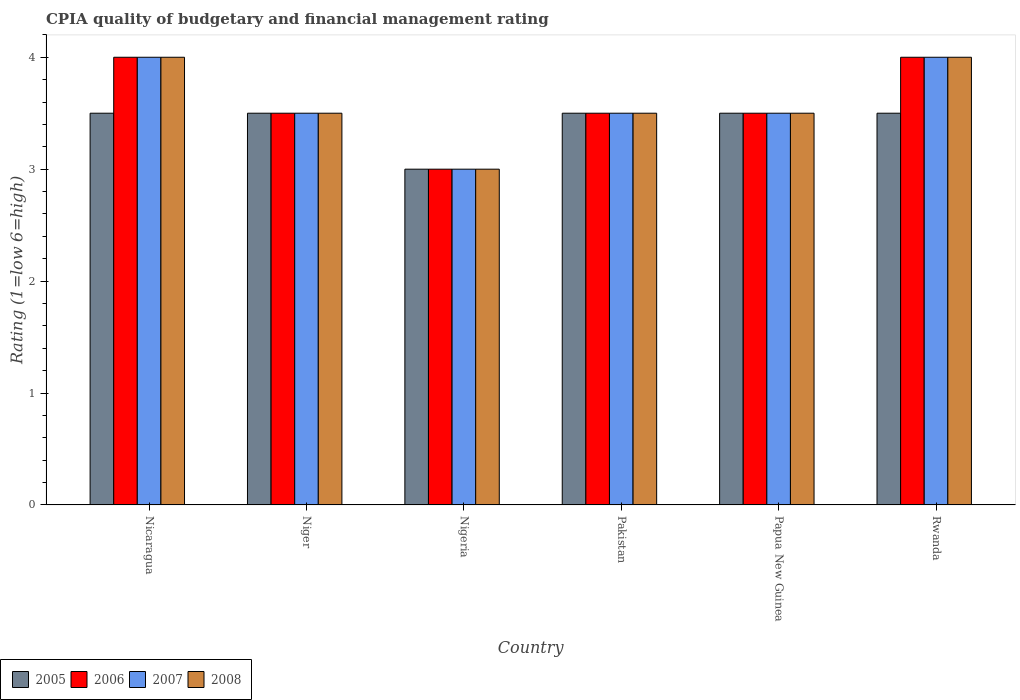How many different coloured bars are there?
Your response must be concise. 4. How many bars are there on the 1st tick from the left?
Your response must be concise. 4. In how many cases, is the number of bars for a given country not equal to the number of legend labels?
Make the answer very short. 0. Across all countries, what is the maximum CPIA rating in 2006?
Provide a short and direct response. 4. In which country was the CPIA rating in 2005 maximum?
Your response must be concise. Nicaragua. In which country was the CPIA rating in 2006 minimum?
Your answer should be very brief. Nigeria. What is the total CPIA rating in 2005 in the graph?
Your answer should be compact. 20.5. What is the average CPIA rating in 2008 per country?
Your response must be concise. 3.58. In how many countries, is the CPIA rating in 2008 greater than 0.8?
Ensure brevity in your answer.  6. Is the difference between the CPIA rating in 2005 in Nicaragua and Niger greater than the difference between the CPIA rating in 2007 in Nicaragua and Niger?
Make the answer very short. No. What is the difference between the highest and the lowest CPIA rating in 2007?
Offer a very short reply. 1. In how many countries, is the CPIA rating in 2005 greater than the average CPIA rating in 2005 taken over all countries?
Your answer should be very brief. 5. What does the 2nd bar from the left in Nigeria represents?
Give a very brief answer. 2006. Are all the bars in the graph horizontal?
Make the answer very short. No. How many countries are there in the graph?
Your response must be concise. 6. Does the graph contain any zero values?
Your answer should be compact. No. Does the graph contain grids?
Provide a succinct answer. No. How are the legend labels stacked?
Offer a very short reply. Horizontal. What is the title of the graph?
Your response must be concise. CPIA quality of budgetary and financial management rating. Does "2003" appear as one of the legend labels in the graph?
Ensure brevity in your answer.  No. What is the label or title of the Y-axis?
Offer a very short reply. Rating (1=low 6=high). What is the Rating (1=low 6=high) in 2005 in Nicaragua?
Ensure brevity in your answer.  3.5. What is the Rating (1=low 6=high) in 2007 in Nicaragua?
Provide a succinct answer. 4. What is the Rating (1=low 6=high) in 2008 in Nicaragua?
Provide a succinct answer. 4. What is the Rating (1=low 6=high) in 2005 in Niger?
Give a very brief answer. 3.5. What is the Rating (1=low 6=high) of 2005 in Nigeria?
Ensure brevity in your answer.  3. What is the Rating (1=low 6=high) in 2006 in Nigeria?
Provide a succinct answer. 3. What is the Rating (1=low 6=high) in 2007 in Nigeria?
Your answer should be compact. 3. What is the Rating (1=low 6=high) in 2008 in Nigeria?
Keep it short and to the point. 3. What is the Rating (1=low 6=high) in 2005 in Pakistan?
Make the answer very short. 3.5. What is the Rating (1=low 6=high) in 2006 in Pakistan?
Make the answer very short. 3.5. What is the Rating (1=low 6=high) of 2006 in Papua New Guinea?
Offer a terse response. 3.5. What is the Rating (1=low 6=high) of 2008 in Papua New Guinea?
Make the answer very short. 3.5. What is the Rating (1=low 6=high) in 2006 in Rwanda?
Keep it short and to the point. 4. Across all countries, what is the maximum Rating (1=low 6=high) of 2006?
Give a very brief answer. 4. Across all countries, what is the maximum Rating (1=low 6=high) of 2007?
Provide a short and direct response. 4. Across all countries, what is the maximum Rating (1=low 6=high) in 2008?
Your response must be concise. 4. What is the total Rating (1=low 6=high) of 2005 in the graph?
Provide a succinct answer. 20.5. What is the total Rating (1=low 6=high) of 2006 in the graph?
Ensure brevity in your answer.  21.5. What is the difference between the Rating (1=low 6=high) in 2005 in Nicaragua and that in Niger?
Your answer should be very brief. 0. What is the difference between the Rating (1=low 6=high) in 2008 in Nicaragua and that in Niger?
Make the answer very short. 0.5. What is the difference between the Rating (1=low 6=high) of 2005 in Nicaragua and that in Nigeria?
Your answer should be very brief. 0.5. What is the difference between the Rating (1=low 6=high) of 2007 in Nicaragua and that in Nigeria?
Your response must be concise. 1. What is the difference between the Rating (1=low 6=high) in 2008 in Nicaragua and that in Nigeria?
Ensure brevity in your answer.  1. What is the difference between the Rating (1=low 6=high) of 2005 in Nicaragua and that in Pakistan?
Provide a short and direct response. 0. What is the difference between the Rating (1=low 6=high) in 2007 in Nicaragua and that in Pakistan?
Provide a succinct answer. 0.5. What is the difference between the Rating (1=low 6=high) in 2008 in Nicaragua and that in Pakistan?
Give a very brief answer. 0.5. What is the difference between the Rating (1=low 6=high) of 2005 in Nicaragua and that in Papua New Guinea?
Provide a succinct answer. 0. What is the difference between the Rating (1=low 6=high) of 2006 in Nicaragua and that in Rwanda?
Your answer should be very brief. 0. What is the difference between the Rating (1=low 6=high) of 2008 in Nicaragua and that in Rwanda?
Make the answer very short. 0. What is the difference between the Rating (1=low 6=high) in 2006 in Niger and that in Nigeria?
Provide a succinct answer. 0.5. What is the difference between the Rating (1=low 6=high) in 2007 in Niger and that in Nigeria?
Make the answer very short. 0.5. What is the difference between the Rating (1=low 6=high) of 2005 in Niger and that in Pakistan?
Provide a short and direct response. 0. What is the difference between the Rating (1=low 6=high) of 2006 in Niger and that in Pakistan?
Keep it short and to the point. 0. What is the difference between the Rating (1=low 6=high) of 2008 in Niger and that in Papua New Guinea?
Give a very brief answer. 0. What is the difference between the Rating (1=low 6=high) in 2005 in Niger and that in Rwanda?
Offer a terse response. 0. What is the difference between the Rating (1=low 6=high) in 2007 in Niger and that in Rwanda?
Your response must be concise. -0.5. What is the difference between the Rating (1=low 6=high) in 2005 in Nigeria and that in Pakistan?
Your answer should be very brief. -0.5. What is the difference between the Rating (1=low 6=high) in 2006 in Nigeria and that in Pakistan?
Give a very brief answer. -0.5. What is the difference between the Rating (1=low 6=high) of 2005 in Nigeria and that in Rwanda?
Offer a terse response. -0.5. What is the difference between the Rating (1=low 6=high) in 2006 in Nigeria and that in Rwanda?
Your response must be concise. -1. What is the difference between the Rating (1=low 6=high) of 2007 in Nigeria and that in Rwanda?
Give a very brief answer. -1. What is the difference between the Rating (1=low 6=high) in 2008 in Nigeria and that in Rwanda?
Your answer should be very brief. -1. What is the difference between the Rating (1=low 6=high) of 2005 in Pakistan and that in Papua New Guinea?
Your answer should be very brief. 0. What is the difference between the Rating (1=low 6=high) of 2006 in Pakistan and that in Papua New Guinea?
Your answer should be very brief. 0. What is the difference between the Rating (1=low 6=high) in 2005 in Pakistan and that in Rwanda?
Make the answer very short. 0. What is the difference between the Rating (1=low 6=high) in 2007 in Pakistan and that in Rwanda?
Your answer should be very brief. -0.5. What is the difference between the Rating (1=low 6=high) in 2006 in Papua New Guinea and that in Rwanda?
Provide a short and direct response. -0.5. What is the difference between the Rating (1=low 6=high) of 2007 in Papua New Guinea and that in Rwanda?
Your answer should be very brief. -0.5. What is the difference between the Rating (1=low 6=high) of 2005 in Nicaragua and the Rating (1=low 6=high) of 2007 in Niger?
Make the answer very short. 0. What is the difference between the Rating (1=low 6=high) of 2005 in Nicaragua and the Rating (1=low 6=high) of 2008 in Niger?
Your answer should be compact. 0. What is the difference between the Rating (1=low 6=high) in 2006 in Nicaragua and the Rating (1=low 6=high) in 2008 in Niger?
Make the answer very short. 0.5. What is the difference between the Rating (1=low 6=high) of 2005 in Nicaragua and the Rating (1=low 6=high) of 2006 in Nigeria?
Your answer should be compact. 0.5. What is the difference between the Rating (1=low 6=high) of 2005 in Nicaragua and the Rating (1=low 6=high) of 2007 in Nigeria?
Your answer should be very brief. 0.5. What is the difference between the Rating (1=low 6=high) in 2005 in Nicaragua and the Rating (1=low 6=high) in 2008 in Nigeria?
Offer a terse response. 0.5. What is the difference between the Rating (1=low 6=high) in 2006 in Nicaragua and the Rating (1=low 6=high) in 2007 in Nigeria?
Make the answer very short. 1. What is the difference between the Rating (1=low 6=high) in 2006 in Nicaragua and the Rating (1=low 6=high) in 2008 in Nigeria?
Offer a terse response. 1. What is the difference between the Rating (1=low 6=high) of 2005 in Nicaragua and the Rating (1=low 6=high) of 2006 in Pakistan?
Give a very brief answer. 0. What is the difference between the Rating (1=low 6=high) in 2005 in Nicaragua and the Rating (1=low 6=high) in 2008 in Pakistan?
Provide a succinct answer. 0. What is the difference between the Rating (1=low 6=high) in 2006 in Nicaragua and the Rating (1=low 6=high) in 2007 in Pakistan?
Your response must be concise. 0.5. What is the difference between the Rating (1=low 6=high) in 2006 in Nicaragua and the Rating (1=low 6=high) in 2008 in Pakistan?
Give a very brief answer. 0.5. What is the difference between the Rating (1=low 6=high) in 2007 in Nicaragua and the Rating (1=low 6=high) in 2008 in Pakistan?
Offer a very short reply. 0.5. What is the difference between the Rating (1=low 6=high) in 2005 in Nicaragua and the Rating (1=low 6=high) in 2006 in Papua New Guinea?
Offer a very short reply. 0. What is the difference between the Rating (1=low 6=high) in 2005 in Nicaragua and the Rating (1=low 6=high) in 2008 in Papua New Guinea?
Make the answer very short. 0. What is the difference between the Rating (1=low 6=high) in 2006 in Nicaragua and the Rating (1=low 6=high) in 2007 in Papua New Guinea?
Your answer should be very brief. 0.5. What is the difference between the Rating (1=low 6=high) of 2006 in Nicaragua and the Rating (1=low 6=high) of 2008 in Papua New Guinea?
Your answer should be very brief. 0.5. What is the difference between the Rating (1=low 6=high) of 2007 in Nicaragua and the Rating (1=low 6=high) of 2008 in Papua New Guinea?
Make the answer very short. 0.5. What is the difference between the Rating (1=low 6=high) in 2005 in Nicaragua and the Rating (1=low 6=high) in 2006 in Rwanda?
Offer a terse response. -0.5. What is the difference between the Rating (1=low 6=high) of 2005 in Nicaragua and the Rating (1=low 6=high) of 2007 in Rwanda?
Your answer should be very brief. -0.5. What is the difference between the Rating (1=low 6=high) of 2005 in Nicaragua and the Rating (1=low 6=high) of 2008 in Rwanda?
Your response must be concise. -0.5. What is the difference between the Rating (1=low 6=high) in 2006 in Nicaragua and the Rating (1=low 6=high) in 2008 in Rwanda?
Make the answer very short. 0. What is the difference between the Rating (1=low 6=high) of 2007 in Nicaragua and the Rating (1=low 6=high) of 2008 in Rwanda?
Your response must be concise. 0. What is the difference between the Rating (1=low 6=high) in 2005 in Niger and the Rating (1=low 6=high) in 2007 in Nigeria?
Keep it short and to the point. 0.5. What is the difference between the Rating (1=low 6=high) in 2006 in Niger and the Rating (1=low 6=high) in 2008 in Nigeria?
Your answer should be compact. 0.5. What is the difference between the Rating (1=low 6=high) of 2007 in Niger and the Rating (1=low 6=high) of 2008 in Nigeria?
Give a very brief answer. 0.5. What is the difference between the Rating (1=low 6=high) of 2005 in Niger and the Rating (1=low 6=high) of 2007 in Pakistan?
Your answer should be compact. 0. What is the difference between the Rating (1=low 6=high) of 2006 in Niger and the Rating (1=low 6=high) of 2007 in Pakistan?
Offer a very short reply. 0. What is the difference between the Rating (1=low 6=high) in 2006 in Niger and the Rating (1=low 6=high) in 2008 in Pakistan?
Provide a succinct answer. 0. What is the difference between the Rating (1=low 6=high) in 2007 in Niger and the Rating (1=low 6=high) in 2008 in Pakistan?
Provide a short and direct response. 0. What is the difference between the Rating (1=low 6=high) of 2005 in Niger and the Rating (1=low 6=high) of 2006 in Papua New Guinea?
Ensure brevity in your answer.  0. What is the difference between the Rating (1=low 6=high) in 2005 in Niger and the Rating (1=low 6=high) in 2007 in Papua New Guinea?
Ensure brevity in your answer.  0. What is the difference between the Rating (1=low 6=high) of 2006 in Niger and the Rating (1=low 6=high) of 2007 in Papua New Guinea?
Your answer should be very brief. 0. What is the difference between the Rating (1=low 6=high) in 2006 in Niger and the Rating (1=low 6=high) in 2008 in Papua New Guinea?
Ensure brevity in your answer.  0. What is the difference between the Rating (1=low 6=high) in 2007 in Niger and the Rating (1=low 6=high) in 2008 in Papua New Guinea?
Provide a short and direct response. 0. What is the difference between the Rating (1=low 6=high) of 2006 in Niger and the Rating (1=low 6=high) of 2007 in Rwanda?
Offer a terse response. -0.5. What is the difference between the Rating (1=low 6=high) in 2006 in Niger and the Rating (1=low 6=high) in 2008 in Rwanda?
Offer a very short reply. -0.5. What is the difference between the Rating (1=low 6=high) in 2007 in Niger and the Rating (1=low 6=high) in 2008 in Rwanda?
Offer a terse response. -0.5. What is the difference between the Rating (1=low 6=high) in 2005 in Nigeria and the Rating (1=low 6=high) in 2006 in Pakistan?
Offer a terse response. -0.5. What is the difference between the Rating (1=low 6=high) in 2005 in Nigeria and the Rating (1=low 6=high) in 2007 in Pakistan?
Your answer should be compact. -0.5. What is the difference between the Rating (1=low 6=high) of 2005 in Nigeria and the Rating (1=low 6=high) of 2008 in Pakistan?
Your response must be concise. -0.5. What is the difference between the Rating (1=low 6=high) of 2006 in Nigeria and the Rating (1=low 6=high) of 2007 in Pakistan?
Offer a very short reply. -0.5. What is the difference between the Rating (1=low 6=high) in 2007 in Nigeria and the Rating (1=low 6=high) in 2008 in Pakistan?
Your answer should be compact. -0.5. What is the difference between the Rating (1=low 6=high) in 2005 in Nigeria and the Rating (1=low 6=high) in 2006 in Papua New Guinea?
Give a very brief answer. -0.5. What is the difference between the Rating (1=low 6=high) in 2006 in Nigeria and the Rating (1=low 6=high) in 2008 in Papua New Guinea?
Your answer should be very brief. -0.5. What is the difference between the Rating (1=low 6=high) of 2005 in Nigeria and the Rating (1=low 6=high) of 2006 in Rwanda?
Your response must be concise. -1. What is the difference between the Rating (1=low 6=high) in 2005 in Nigeria and the Rating (1=low 6=high) in 2008 in Rwanda?
Make the answer very short. -1. What is the difference between the Rating (1=low 6=high) in 2006 in Nigeria and the Rating (1=low 6=high) in 2007 in Rwanda?
Provide a short and direct response. -1. What is the difference between the Rating (1=low 6=high) in 2006 in Nigeria and the Rating (1=low 6=high) in 2008 in Rwanda?
Ensure brevity in your answer.  -1. What is the difference between the Rating (1=low 6=high) in 2007 in Nigeria and the Rating (1=low 6=high) in 2008 in Rwanda?
Your answer should be compact. -1. What is the difference between the Rating (1=low 6=high) in 2005 in Pakistan and the Rating (1=low 6=high) in 2006 in Papua New Guinea?
Your answer should be very brief. 0. What is the difference between the Rating (1=low 6=high) of 2005 in Pakistan and the Rating (1=low 6=high) of 2006 in Rwanda?
Offer a terse response. -0.5. What is the difference between the Rating (1=low 6=high) in 2007 in Pakistan and the Rating (1=low 6=high) in 2008 in Rwanda?
Give a very brief answer. -0.5. What is the difference between the Rating (1=low 6=high) of 2005 in Papua New Guinea and the Rating (1=low 6=high) of 2006 in Rwanda?
Your answer should be compact. -0.5. What is the difference between the Rating (1=low 6=high) of 2006 in Papua New Guinea and the Rating (1=low 6=high) of 2008 in Rwanda?
Provide a short and direct response. -0.5. What is the average Rating (1=low 6=high) in 2005 per country?
Make the answer very short. 3.42. What is the average Rating (1=low 6=high) in 2006 per country?
Offer a terse response. 3.58. What is the average Rating (1=low 6=high) of 2007 per country?
Your answer should be compact. 3.58. What is the average Rating (1=low 6=high) in 2008 per country?
Provide a succinct answer. 3.58. What is the difference between the Rating (1=low 6=high) of 2005 and Rating (1=low 6=high) of 2006 in Nicaragua?
Provide a short and direct response. -0.5. What is the difference between the Rating (1=low 6=high) in 2006 and Rating (1=low 6=high) in 2008 in Nicaragua?
Ensure brevity in your answer.  0. What is the difference between the Rating (1=low 6=high) of 2005 and Rating (1=low 6=high) of 2007 in Niger?
Provide a succinct answer. 0. What is the difference between the Rating (1=low 6=high) in 2005 and Rating (1=low 6=high) in 2008 in Niger?
Keep it short and to the point. 0. What is the difference between the Rating (1=low 6=high) of 2005 and Rating (1=low 6=high) of 2007 in Nigeria?
Your answer should be compact. 0. What is the difference between the Rating (1=low 6=high) of 2007 and Rating (1=low 6=high) of 2008 in Nigeria?
Provide a short and direct response. 0. What is the difference between the Rating (1=low 6=high) of 2005 and Rating (1=low 6=high) of 2006 in Pakistan?
Your answer should be compact. 0. What is the difference between the Rating (1=low 6=high) of 2005 and Rating (1=low 6=high) of 2007 in Pakistan?
Offer a terse response. 0. What is the difference between the Rating (1=low 6=high) of 2006 and Rating (1=low 6=high) of 2007 in Pakistan?
Give a very brief answer. 0. What is the difference between the Rating (1=low 6=high) of 2007 and Rating (1=low 6=high) of 2008 in Pakistan?
Make the answer very short. 0. What is the difference between the Rating (1=low 6=high) of 2005 and Rating (1=low 6=high) of 2008 in Papua New Guinea?
Give a very brief answer. 0. What is the difference between the Rating (1=low 6=high) of 2005 and Rating (1=low 6=high) of 2007 in Rwanda?
Your answer should be very brief. -0.5. What is the difference between the Rating (1=low 6=high) in 2006 and Rating (1=low 6=high) in 2007 in Rwanda?
Ensure brevity in your answer.  0. What is the difference between the Rating (1=low 6=high) in 2007 and Rating (1=low 6=high) in 2008 in Rwanda?
Offer a terse response. 0. What is the ratio of the Rating (1=low 6=high) of 2005 in Nicaragua to that in Niger?
Offer a very short reply. 1. What is the ratio of the Rating (1=low 6=high) in 2007 in Nicaragua to that in Niger?
Your response must be concise. 1.14. What is the ratio of the Rating (1=low 6=high) in 2008 in Nicaragua to that in Niger?
Your answer should be compact. 1.14. What is the ratio of the Rating (1=low 6=high) in 2007 in Nicaragua to that in Nigeria?
Provide a short and direct response. 1.33. What is the ratio of the Rating (1=low 6=high) of 2008 in Nicaragua to that in Nigeria?
Make the answer very short. 1.33. What is the ratio of the Rating (1=low 6=high) in 2005 in Nicaragua to that in Pakistan?
Keep it short and to the point. 1. What is the ratio of the Rating (1=low 6=high) in 2006 in Nicaragua to that in Pakistan?
Your answer should be very brief. 1.14. What is the ratio of the Rating (1=low 6=high) in 2008 in Nicaragua to that in Pakistan?
Your answer should be very brief. 1.14. What is the ratio of the Rating (1=low 6=high) of 2006 in Nicaragua to that in Papua New Guinea?
Provide a short and direct response. 1.14. What is the ratio of the Rating (1=low 6=high) in 2008 in Nicaragua to that in Papua New Guinea?
Offer a very short reply. 1.14. What is the ratio of the Rating (1=low 6=high) of 2005 in Nicaragua to that in Rwanda?
Ensure brevity in your answer.  1. What is the ratio of the Rating (1=low 6=high) in 2007 in Nicaragua to that in Rwanda?
Give a very brief answer. 1. What is the ratio of the Rating (1=low 6=high) in 2008 in Nicaragua to that in Rwanda?
Provide a succinct answer. 1. What is the ratio of the Rating (1=low 6=high) in 2005 in Niger to that in Nigeria?
Give a very brief answer. 1.17. What is the ratio of the Rating (1=low 6=high) in 2006 in Niger to that in Pakistan?
Give a very brief answer. 1. What is the ratio of the Rating (1=low 6=high) in 2007 in Niger to that in Pakistan?
Keep it short and to the point. 1. What is the ratio of the Rating (1=low 6=high) of 2005 in Niger to that in Papua New Guinea?
Provide a succinct answer. 1. What is the ratio of the Rating (1=low 6=high) in 2007 in Niger to that in Rwanda?
Offer a terse response. 0.88. What is the ratio of the Rating (1=low 6=high) of 2008 in Niger to that in Rwanda?
Offer a terse response. 0.88. What is the ratio of the Rating (1=low 6=high) in 2007 in Nigeria to that in Pakistan?
Offer a terse response. 0.86. What is the ratio of the Rating (1=low 6=high) in 2005 in Nigeria to that in Papua New Guinea?
Provide a succinct answer. 0.86. What is the ratio of the Rating (1=low 6=high) of 2007 in Nigeria to that in Papua New Guinea?
Make the answer very short. 0.86. What is the ratio of the Rating (1=low 6=high) in 2005 in Nigeria to that in Rwanda?
Make the answer very short. 0.86. What is the ratio of the Rating (1=low 6=high) in 2006 in Nigeria to that in Rwanda?
Provide a short and direct response. 0.75. What is the ratio of the Rating (1=low 6=high) in 2005 in Pakistan to that in Papua New Guinea?
Give a very brief answer. 1. What is the ratio of the Rating (1=low 6=high) of 2006 in Pakistan to that in Papua New Guinea?
Your answer should be very brief. 1. What is the ratio of the Rating (1=low 6=high) in 2008 in Pakistan to that in Papua New Guinea?
Make the answer very short. 1. What is the ratio of the Rating (1=low 6=high) of 2005 in Pakistan to that in Rwanda?
Offer a very short reply. 1. What is the ratio of the Rating (1=low 6=high) in 2006 in Pakistan to that in Rwanda?
Provide a short and direct response. 0.88. What is the ratio of the Rating (1=low 6=high) in 2007 in Pakistan to that in Rwanda?
Keep it short and to the point. 0.88. What is the ratio of the Rating (1=low 6=high) of 2005 in Papua New Guinea to that in Rwanda?
Ensure brevity in your answer.  1. What is the ratio of the Rating (1=low 6=high) in 2006 in Papua New Guinea to that in Rwanda?
Offer a very short reply. 0.88. What is the difference between the highest and the second highest Rating (1=low 6=high) in 2006?
Offer a very short reply. 0. What is the difference between the highest and the lowest Rating (1=low 6=high) of 2007?
Provide a succinct answer. 1. What is the difference between the highest and the lowest Rating (1=low 6=high) of 2008?
Keep it short and to the point. 1. 